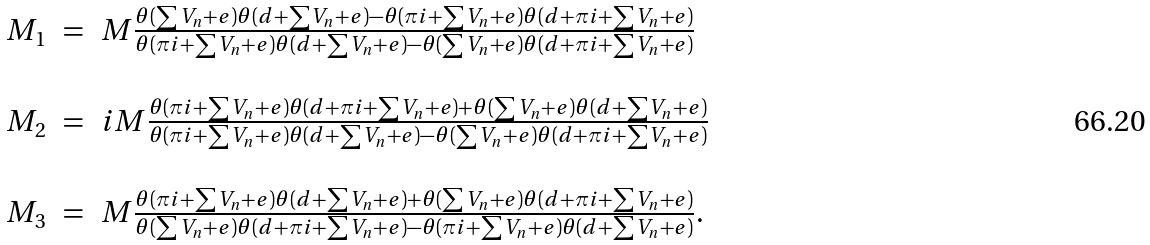<formula> <loc_0><loc_0><loc_500><loc_500>\begin{array} { r c l } M _ { 1 } & = & M \frac { \theta ( \sum V _ { n } + e ) \theta ( d + \sum V _ { n } + e ) - \theta ( \pi i + \sum V _ { n } + e ) \theta ( d + \pi i + \sum V _ { n } + e ) } { \theta ( \pi i + \sum V _ { n } + e ) \theta ( d + \sum V _ { n } + e ) - \theta ( \sum V _ { n } + e ) \theta ( d + \pi i + \sum V _ { n } + e ) } \\ & & \\ M _ { 2 } & = & i M \frac { \theta ( \pi i + \sum V _ { n } + e ) \theta ( d + \pi i + \sum V _ { n } + e ) + \theta ( \sum V _ { n } + e ) \theta ( d + \sum V _ { n } + e ) } { \theta ( \pi i + \sum V _ { n } + e ) \theta ( d + \sum V _ { n } + e ) - \theta ( \sum V _ { n } + e ) \theta ( d + \pi i + \sum V _ { n } + e ) } \\ & & \\ M _ { 3 } & = & M \frac { \theta ( \pi i + \sum V _ { n } + e ) \theta ( d + \sum V _ { n } + e ) + \theta ( \sum V _ { n } + e ) \theta ( d + \pi i + \sum V _ { n } + e ) } { \theta ( \sum V _ { n } + e ) \theta ( d + \pi i + \sum V _ { n } + e ) - \theta ( \pi i + \sum V _ { n } + e ) \theta ( d + \sum V _ { n } + e ) } . \end{array}</formula> 